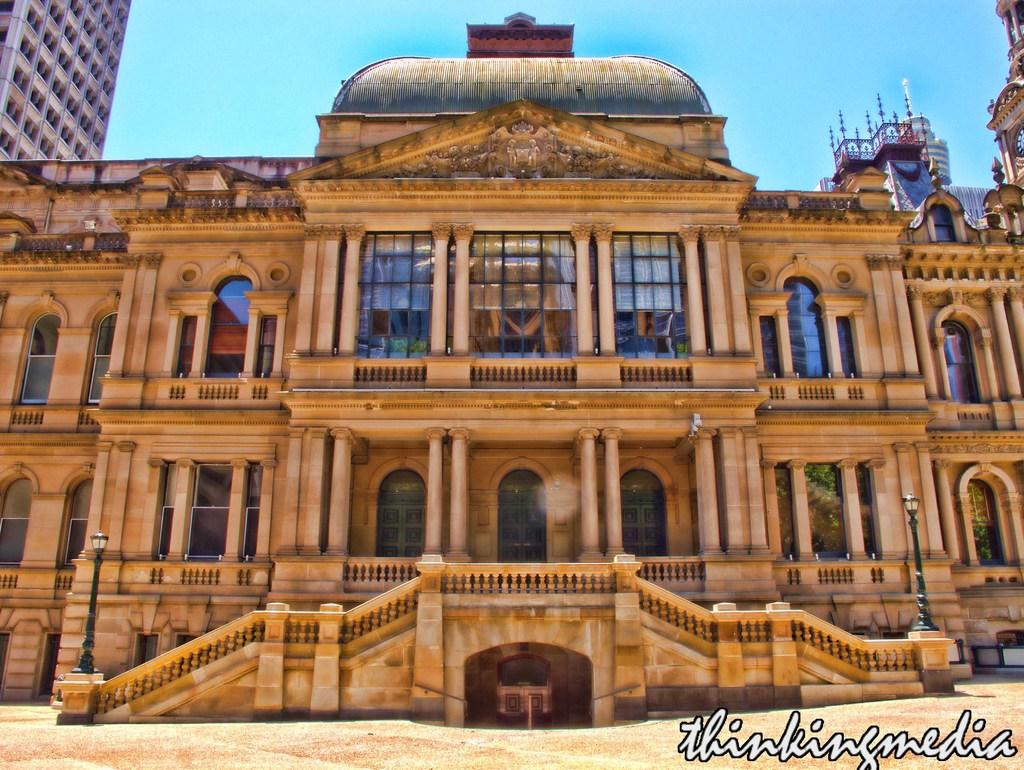Provide a one-sentence caption for the provided image. A beige building with "Thinking Media" written below it. 